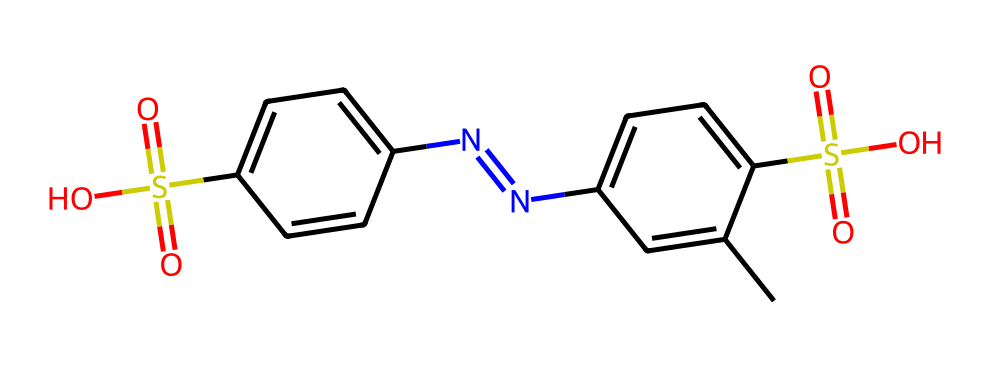What is the total number of carbon atoms in the chemical? By examining the SMILES representation, I can count the number of carbon (C) symbols present. In this case, the structure contains a total of 14 carbon atoms.
Answer: 14 How many sulfur atoms are present in the chemical? In the SMILES, the distinct 'S' symbols represent sulfur atoms. Here, there are 2 sulfur atoms indicated in the structure.
Answer: 2 What functional groups are present in this chemical? Looking at the structural features indicated by the SMILES, there are sulfonic acid groups (–SO3H) and amine groups (–NH) visible. The two sulfonic acids are clearly mentioned in the structure.
Answer: sulfonic acid and amine What is the molecular formula for this chemical? By counting the atoms represented in the SMILES notation: C=14, H=16, N=4, O=4, S=2 gives the complete formula of C14H16N4O4S2.
Answer: C14H16N4O4S2 What type of bonding is predominant in this chemical? The structure contains multiple types of bonding such as covalent bonds (between C, N, and O atoms) and possibly ionic interactions due to the charged sulfonic acid groups. Given the context, covalent bonding is the predominant type.
Answer: covalent What is the approximate molecular weight of this chemical? To find the molecular weight, calculate using the atomic weights based on the molecular formula: (14*12.01) + (16*1.008) + (4*14.01) + (4*16.00) + (2*32.07) approximates to 392.5 g/mol.
Answer: 392.5 g/mol What type of chemical is this? Based on the structure and the presence of both aromatic rings and sulfonic acid groups, this compound is classified as an organosulfur compound.
Answer: organosulfur compound 